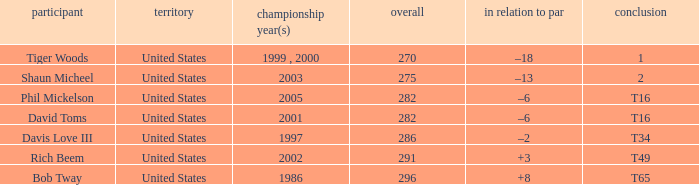What is the to par number of the person who won in 2003? –13. 